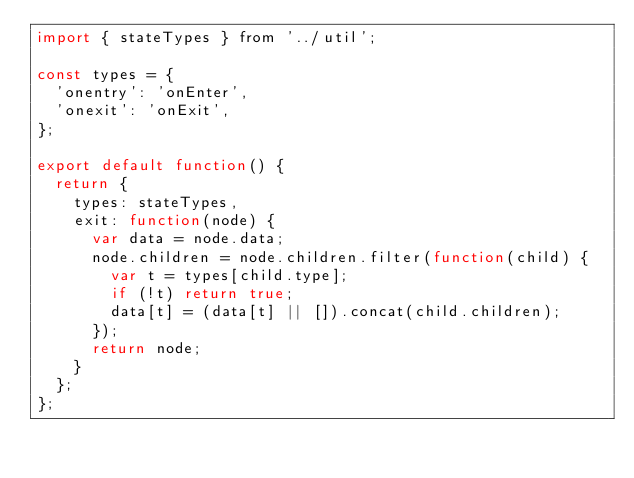Convert code to text. <code><loc_0><loc_0><loc_500><loc_500><_JavaScript_>import { stateTypes } from '../util';

const types = {
  'onentry': 'onEnter',
  'onexit': 'onExit',
};

export default function() {
  return {
    types: stateTypes,
    exit: function(node) {
      var data = node.data;
      node.children = node.children.filter(function(child) {
        var t = types[child.type];
        if (!t) return true;
        data[t] = (data[t] || []).concat(child.children);
      });
      return node;
    }
  };
};
</code> 